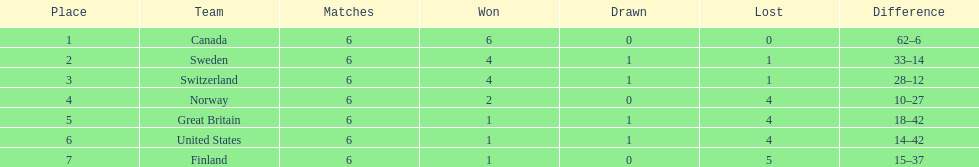How many teams won 6 matches? 1. 